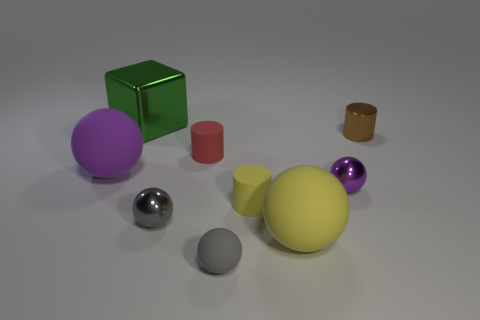What number of other objects are the same color as the tiny matte ball?
Make the answer very short. 1. What is the material of the other ball that is the same color as the tiny matte ball?
Your answer should be very brief. Metal. Is the tiny purple object made of the same material as the small yellow object?
Ensure brevity in your answer.  No. What number of red objects have the same material as the tiny yellow object?
Offer a terse response. 1. What is the color of the small ball that is the same material as the small red cylinder?
Offer a terse response. Gray. There is a small gray shiny thing; what shape is it?
Your response must be concise. Sphere. There is a small gray thing in front of the large yellow ball; what is it made of?
Your answer should be very brief. Rubber. Is there a rubber ball of the same color as the metallic cylinder?
Offer a very short reply. No. What shape is the yellow rubber thing that is the same size as the green object?
Offer a very short reply. Sphere. What color is the small metallic ball behind the tiny yellow rubber cylinder?
Your answer should be compact. Purple. 